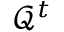Convert formula to latex. <formula><loc_0><loc_0><loc_500><loc_500>\mathcal { Q } ^ { t }</formula> 